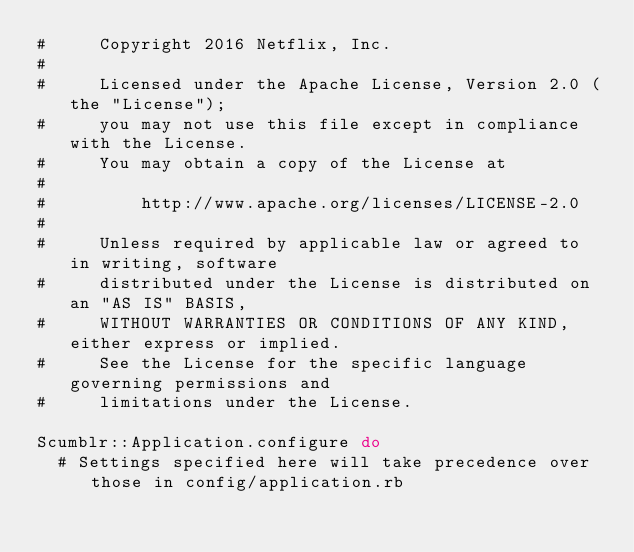Convert code to text. <code><loc_0><loc_0><loc_500><loc_500><_Ruby_>#     Copyright 2016 Netflix, Inc.
#
#     Licensed under the Apache License, Version 2.0 (the "License");
#     you may not use this file except in compliance with the License.
#     You may obtain a copy of the License at
#
#         http://www.apache.org/licenses/LICENSE-2.0
#
#     Unless required by applicable law or agreed to in writing, software
#     distributed under the License is distributed on an "AS IS" BASIS,
#     WITHOUT WARRANTIES OR CONDITIONS OF ANY KIND, either express or implied.
#     See the License for the specific language governing permissions and
#     limitations under the License.

Scumblr::Application.configure do
  # Settings specified here will take precedence over those in config/application.rb
</code> 